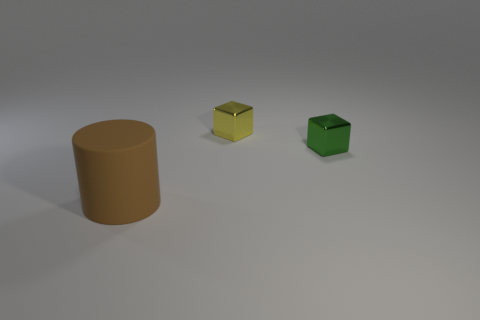Are there any other things that have the same size as the brown matte thing?
Give a very brief answer. No. Is there any other thing that is the same material as the brown cylinder?
Ensure brevity in your answer.  No. What material is the big brown thing that is on the left side of the small cube behind the small green object made of?
Keep it short and to the point. Rubber. Are there any small green cylinders made of the same material as the tiny yellow object?
Give a very brief answer. No. Is there a metal cube that is behind the metallic block to the right of the yellow cube?
Make the answer very short. Yes. What is the small cube that is to the right of the small yellow metal block made of?
Your response must be concise. Metal. Do the yellow metallic object and the small green object have the same shape?
Offer a very short reply. Yes. There is a object in front of the small metallic block in front of the block that is behind the green shiny thing; what is its color?
Ensure brevity in your answer.  Brown. How many other metal things have the same shape as the tiny green metallic thing?
Offer a terse response. 1. What is the size of the thing to the left of the small shiny block on the left side of the tiny green object?
Keep it short and to the point. Large. 